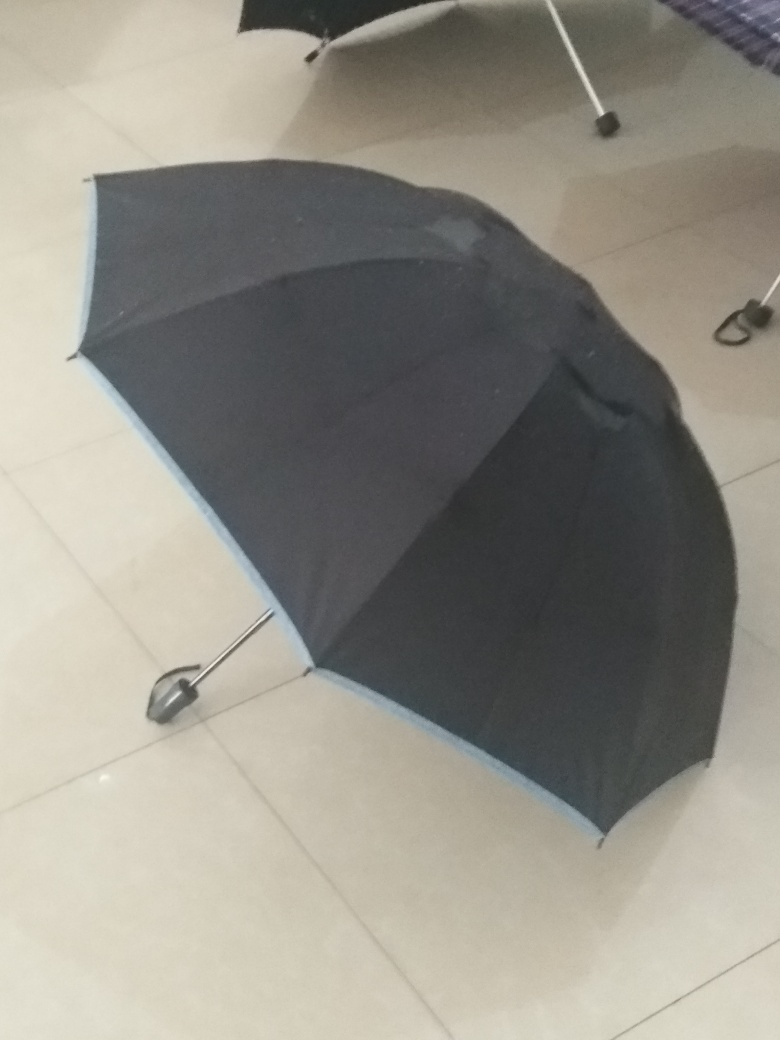How does the umbrella's color contrast with its surroundings? The black and blue colors of the umbrella provide a subtle contrast against the light-colored tiles of the floor. The darker hues of the umbrella draw the eye, making it the focal point against the more neutral background of the floor. 